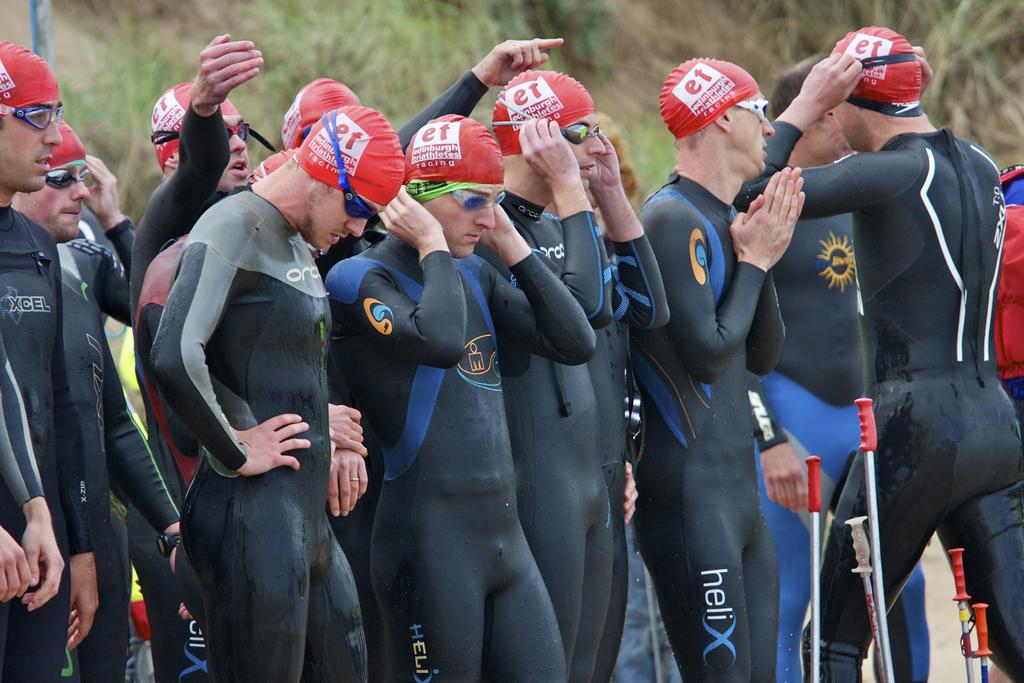How many people are in the image? There is a group of people in the image. What are the people doing in the image? The people are standing in the image. What accessories are the people wearing in the image? The people are wearing caps and goggles in the image. What objects can be seen in the image besides the people? There are sticks and plants visible in the image. What is present in the background of the image? There is a pole in the background of the image. Can you hear the robin singing in the image? There is no robin present in the image, so it is not possible to hear it singing. 